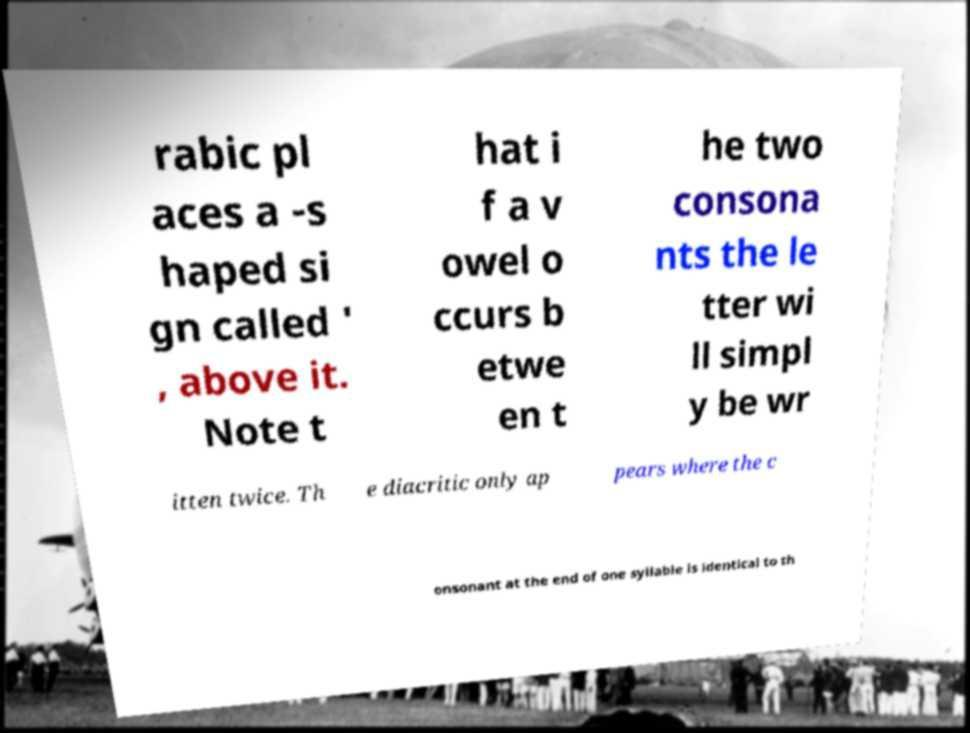Could you assist in decoding the text presented in this image and type it out clearly? rabic pl aces a -s haped si gn called ' , above it. Note t hat i f a v owel o ccurs b etwe en t he two consona nts the le tter wi ll simpl y be wr itten twice. Th e diacritic only ap pears where the c onsonant at the end of one syllable is identical to th 